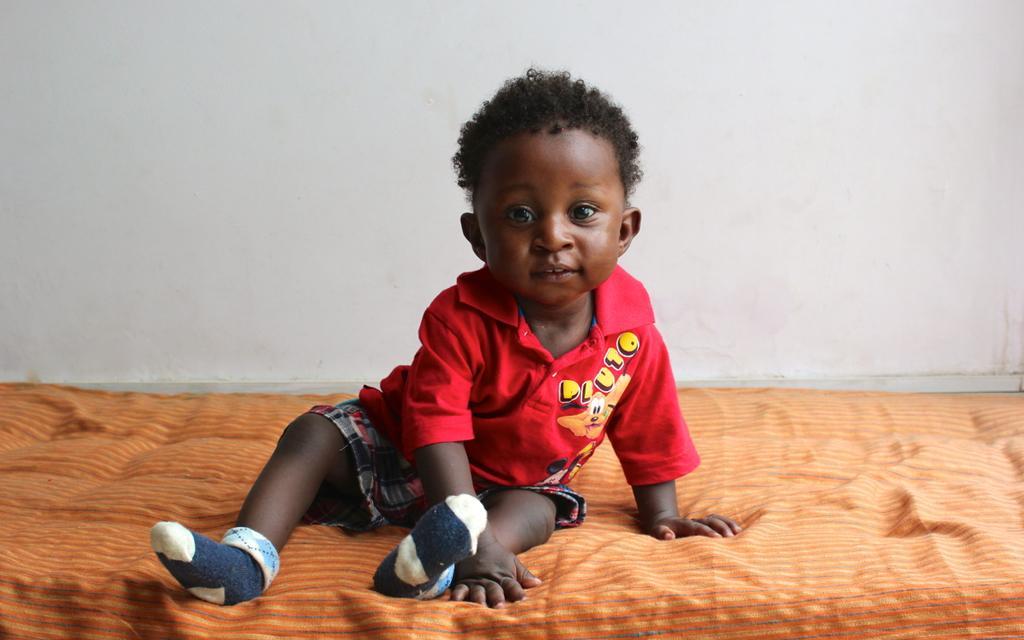How would you summarize this image in a sentence or two? In this image I can see a baby sitting on the orange color bed. He is wearing red top and multi color short. The wall is in white color. 